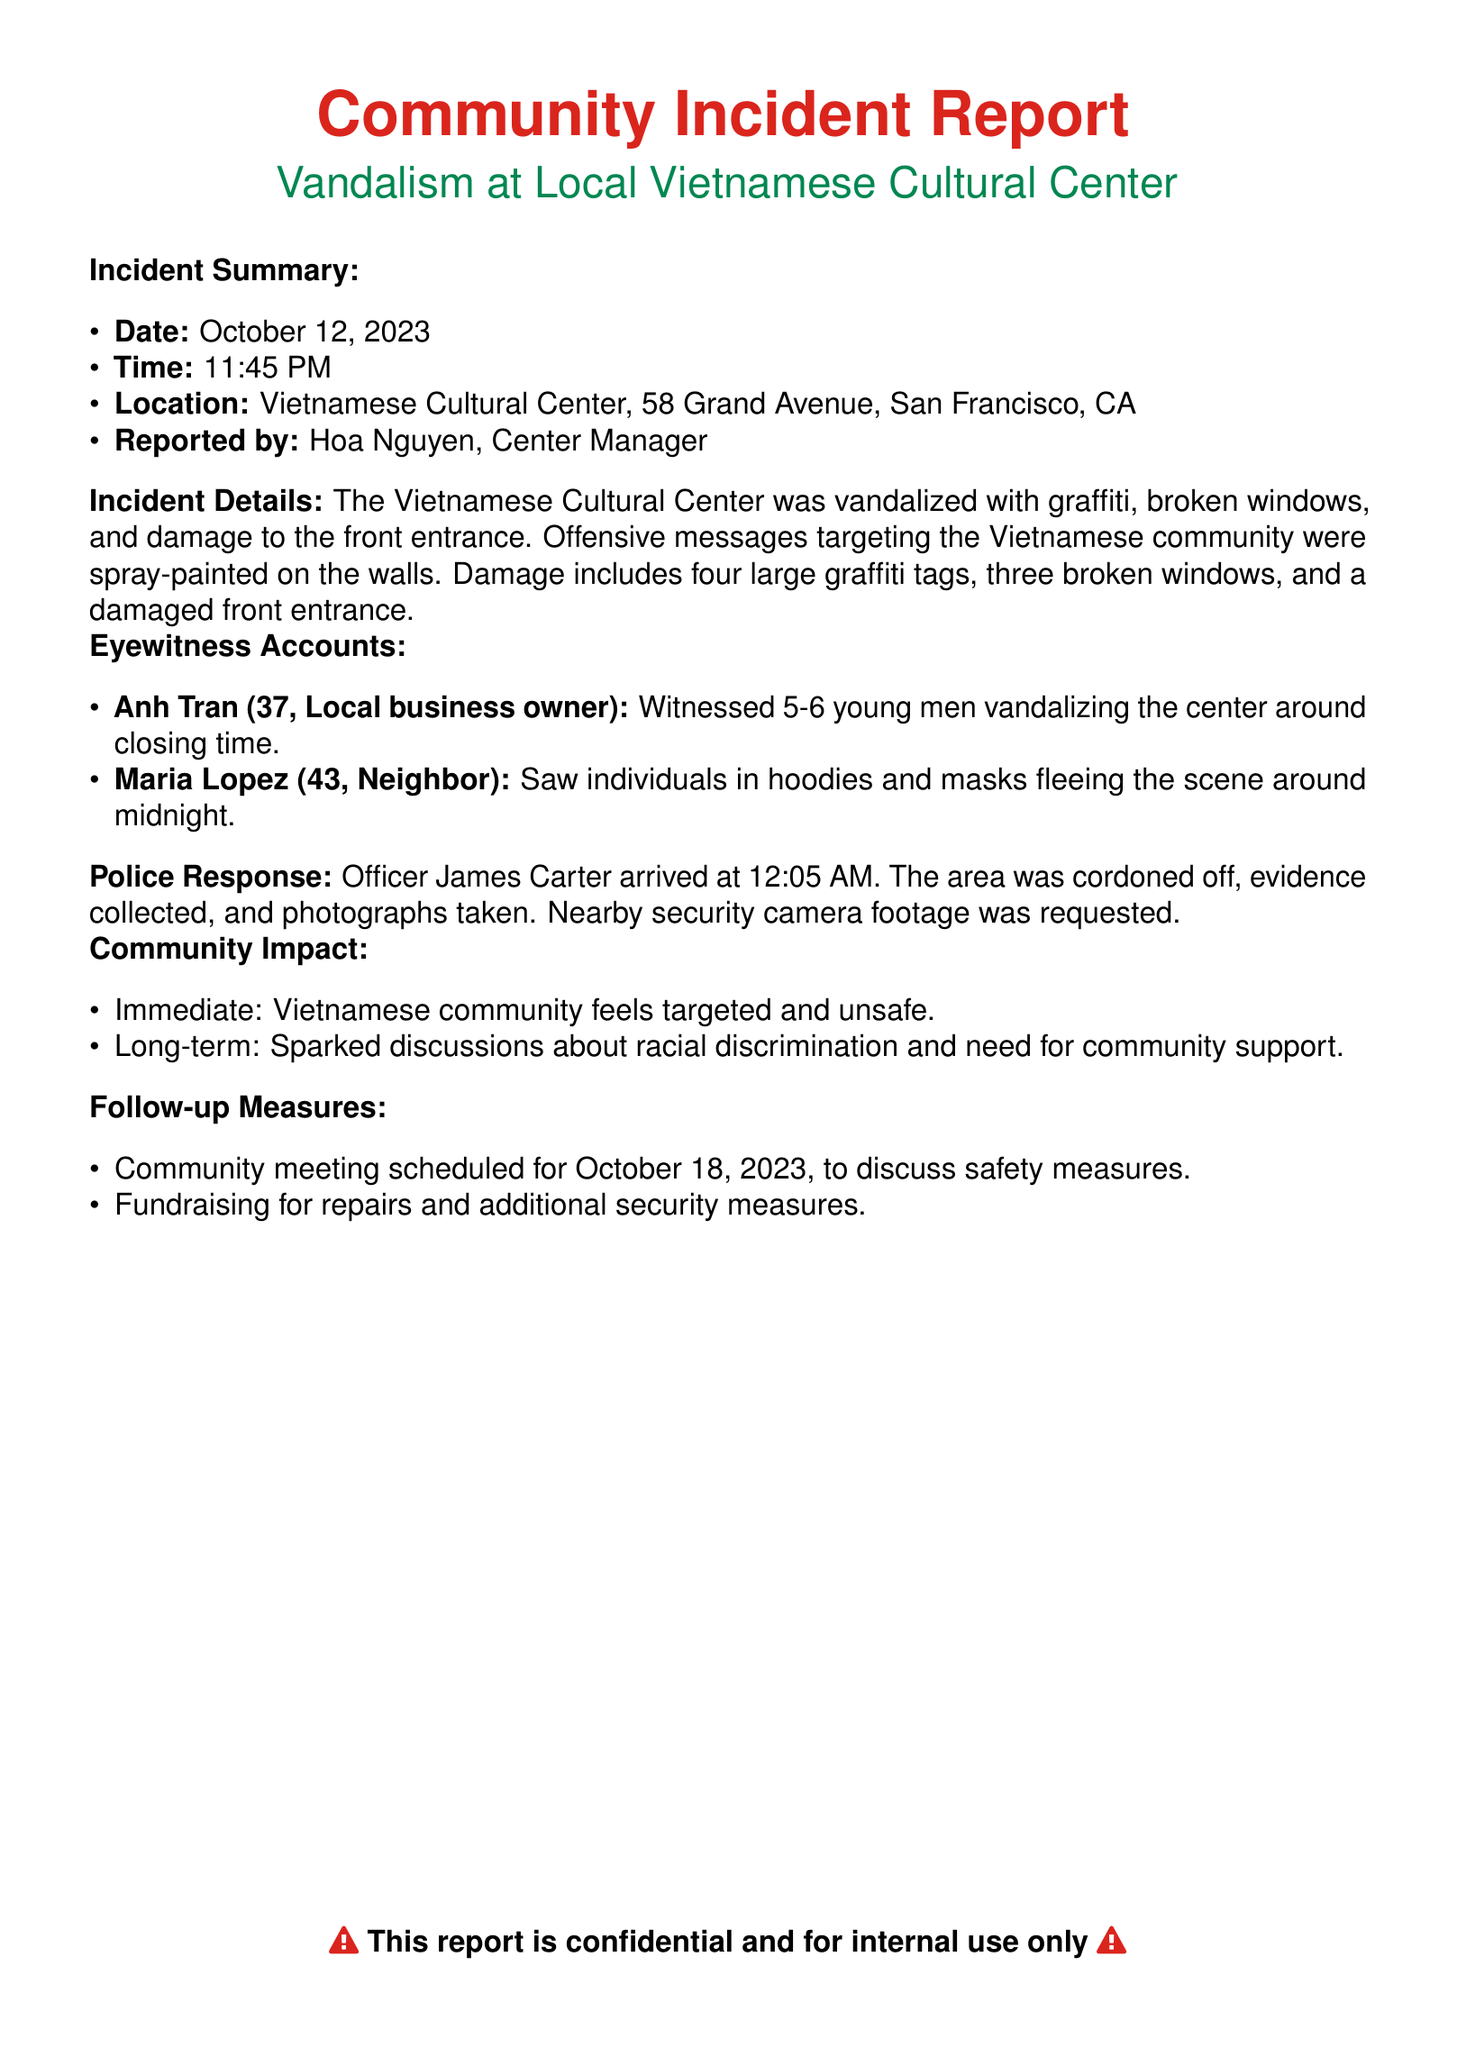What was the incident date? The incident date can be found in the incident summary section of the document.
Answer: October 12, 2023 Who reported the incident? The person who reported the incident is mentioned directly in the report.
Answer: Hoa Nguyen How many broken windows were there? The number of broken windows is explicitly stated in the incident details section.
Answer: Three What time did the police officer arrive? The police response timing is detailed under the police response section.
Answer: 12:05 AM What phrases were used to describe the feelings of the Vietnamese community? The community impact section provides insights into how the community feels after the incident.
Answer: Targeted and unsafe How many graffiti tags were found? The number of graffiti tags is indicated in the incident details.
Answer: Four What action is scheduled for October 18, 2023? The follow-up measures indicate an event planned for that date.
Answer: Community meeting What did Maria Lopez observe? Eyewitness accounts provide specific statements from witnesses, including her observation.
Answer: Individuals in hoodies and masks fleeing the scene 